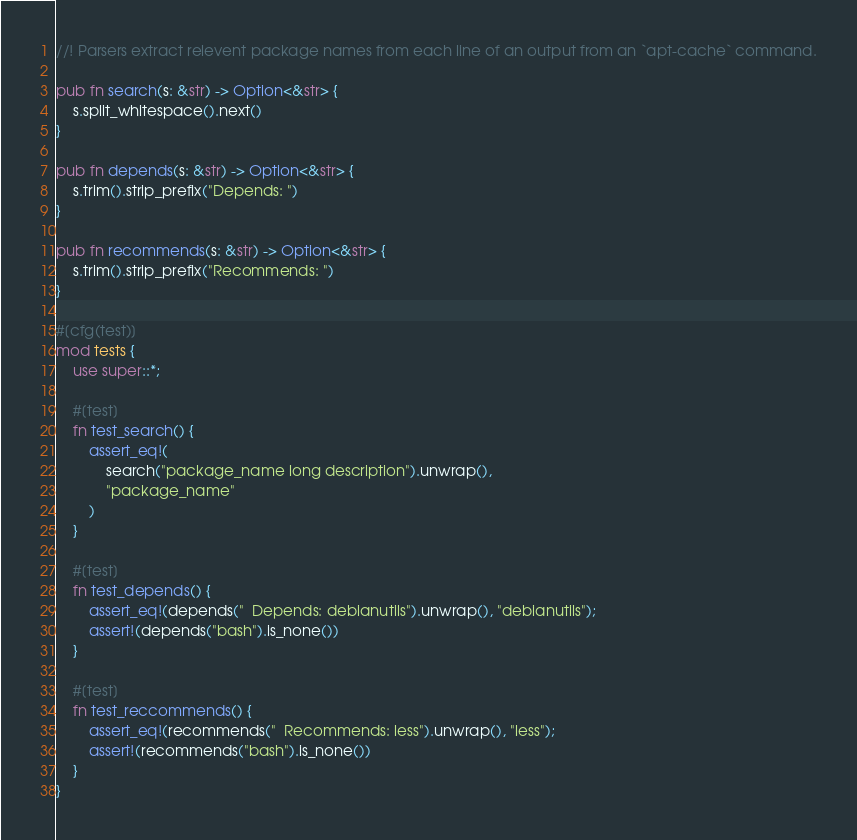Convert code to text. <code><loc_0><loc_0><loc_500><loc_500><_Rust_>//! Parsers extract relevent package names from each line of an output from an `apt-cache` command.

pub fn search(s: &str) -> Option<&str> {
    s.split_whitespace().next()
}

pub fn depends(s: &str) -> Option<&str> {
    s.trim().strip_prefix("Depends: ")
}

pub fn recommends(s: &str) -> Option<&str> {
    s.trim().strip_prefix("Recommends: ")
}

#[cfg(test)]
mod tests {
    use super::*;

    #[test]
    fn test_search() {
        assert_eq!(
            search("package_name long description").unwrap(),
            "package_name"
        )
    }

    #[test]
    fn test_depends() {
        assert_eq!(depends("  Depends: debianutils").unwrap(), "debianutils");
        assert!(depends("bash").is_none())
    }

    #[test]
    fn test_reccommends() {
        assert_eq!(recommends("  Recommends: less").unwrap(), "less");
        assert!(recommends("bash").is_none())
    }
}
</code> 